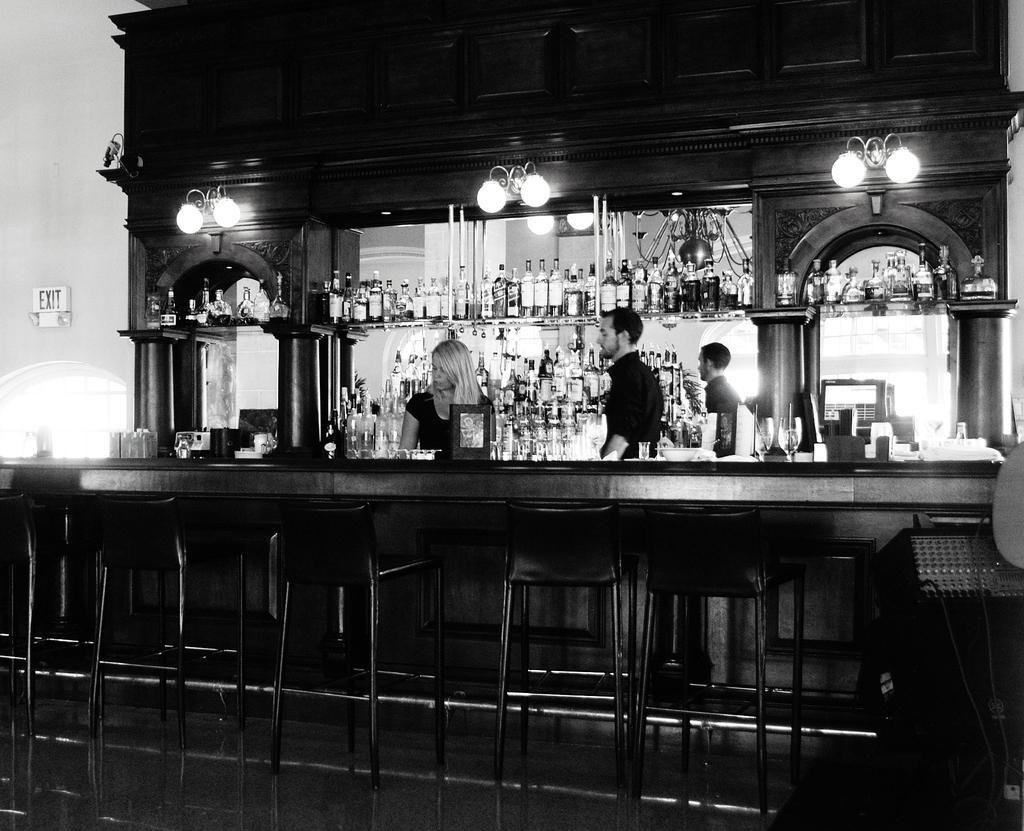Describe this image in one or two sentences. This is a black and white picture. Here we can see a woman and a man. These are the bottles and there are lights. 